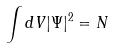<formula> <loc_0><loc_0><loc_500><loc_500>\int d V | \Psi | ^ { 2 } = N</formula> 